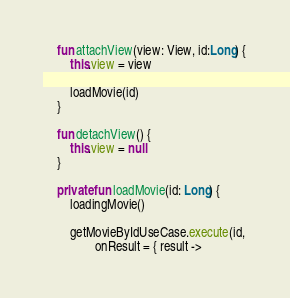<code> <loc_0><loc_0><loc_500><loc_500><_Kotlin_>
    fun attachView(view: View, id:Long) {
        this.view = view

        loadMovie(id)
    }

    fun detachView() {
        this.view = null
    }

    private fun loadMovie(id: Long) {
        loadingMovie()

        getMovieByIdUseCase.execute(id,
                onResult = { result -></code> 